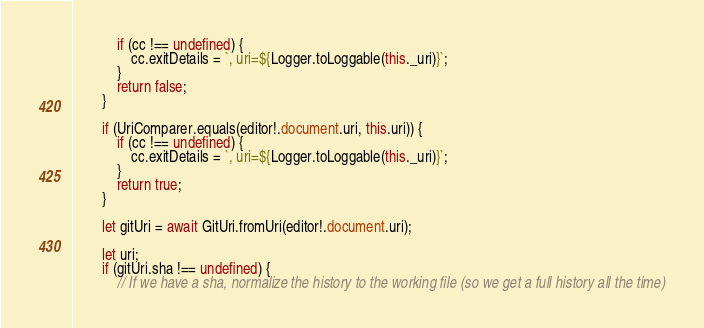Convert code to text. <code><loc_0><loc_0><loc_500><loc_500><_TypeScript_>            if (cc !== undefined) {
                cc.exitDetails = `, uri=${Logger.toLoggable(this._uri)}`;
            }
            return false;
        }

        if (UriComparer.equals(editor!.document.uri, this.uri)) {
            if (cc !== undefined) {
                cc.exitDetails = `, uri=${Logger.toLoggable(this._uri)}`;
            }
            return true;
        }

        let gitUri = await GitUri.fromUri(editor!.document.uri);

        let uri;
        if (gitUri.sha !== undefined) {
            // If we have a sha, normalize the history to the working file (so we get a full history all the time)</code> 